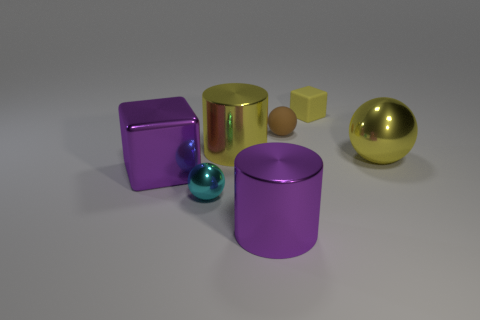There is a object that is in front of the tiny ball that is in front of the brown matte sphere to the left of the large shiny ball; what is its shape?
Your answer should be compact. Cylinder. How many other things are there of the same shape as the tiny yellow matte object?
Your answer should be compact. 1. What is the color of the matte ball that is the same size as the cyan metallic ball?
Give a very brief answer. Brown. How many spheres are either large purple things or brown things?
Keep it short and to the point. 1. What number of tiny balls are there?
Your answer should be very brief. 2. Does the cyan object have the same shape as the big object that is right of the small brown thing?
Keep it short and to the point. Yes. The metallic cylinder that is the same color as the big shiny block is what size?
Offer a terse response. Large. How many things are either brown metal cylinders or yellow things?
Give a very brief answer. 3. The large yellow object behind the shiny sphere to the right of the small shiny object is what shape?
Offer a terse response. Cylinder. Is the shape of the big shiny object that is to the left of the cyan object the same as  the tiny yellow object?
Offer a very short reply. Yes. 